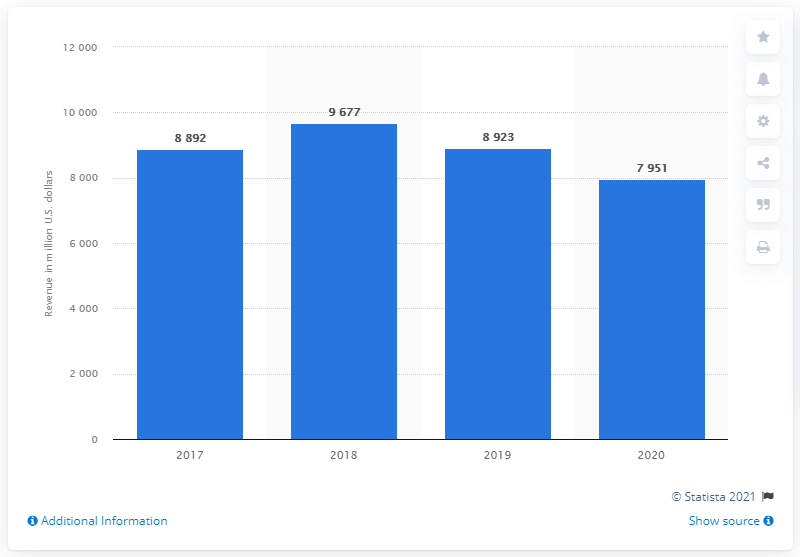Indicate a few pertinent items in this graphic. The Dow generated a revenue of 7,951 in 2020. 